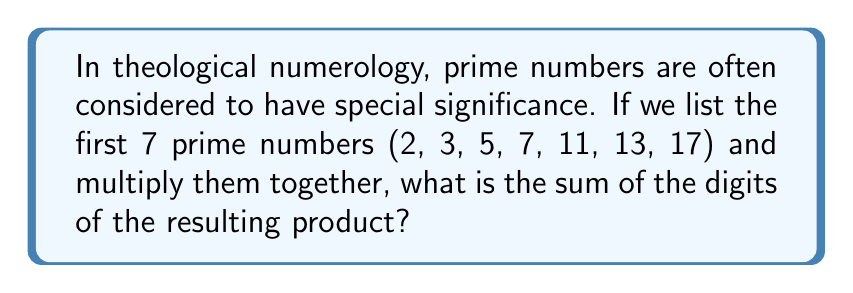Show me your answer to this math problem. Let's approach this step-by-step:

1) First, we need to multiply the first 7 prime numbers:
   $$2 \times 3 \times 5 \times 7 \times 11 \times 13 \times 17$$

2) Let's calculate this product:
   $$2 \times 3 = 6$$
   $$6 \times 5 = 30$$
   $$30 \times 7 = 210$$
   $$210 \times 11 = 2,310$$
   $$2,310 \times 13 = 30,030$$
   $$30,030 \times 17 = 510,510$$

3) So, the product of the first 7 prime numbers is 510,510.

4) Now, we need to sum the digits of this number:
   $$5 + 1 + 0 + 5 + 1 + 0 = 12$$

5) Therefore, the sum of the digits is 12.

This result, 12, is itself a theologically significant number in many traditions, often representing completeness or divine governance.
Answer: 12 